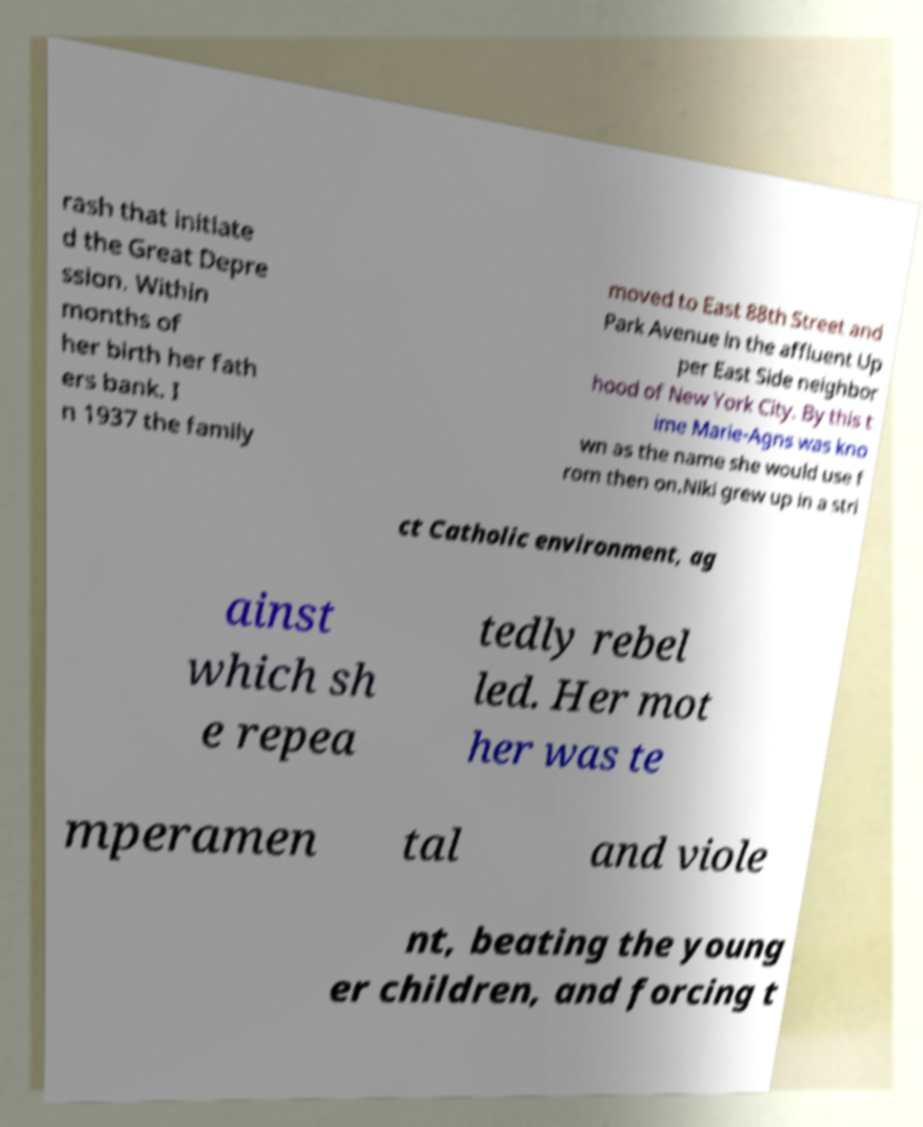Could you assist in decoding the text presented in this image and type it out clearly? rash that initiate d the Great Depre ssion. Within months of her birth her fath ers bank. I n 1937 the family moved to East 88th Street and Park Avenue in the affluent Up per East Side neighbor hood of New York City. By this t ime Marie-Agns was kno wn as the name she would use f rom then on.Niki grew up in a stri ct Catholic environment, ag ainst which sh e repea tedly rebel led. Her mot her was te mperamen tal and viole nt, beating the young er children, and forcing t 